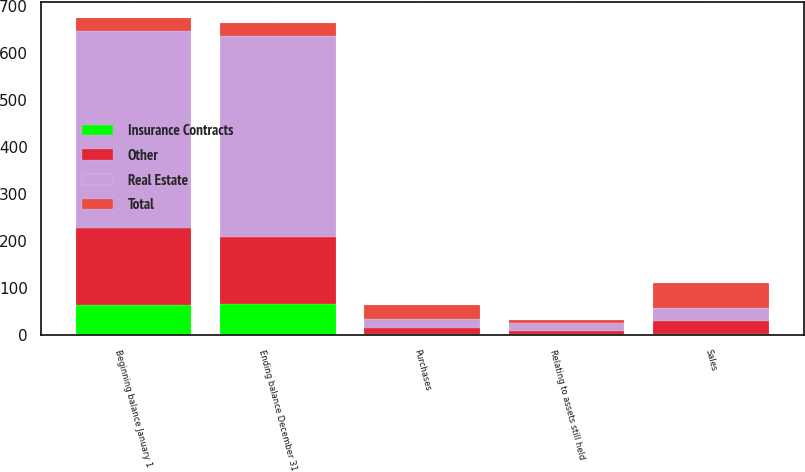Convert chart. <chart><loc_0><loc_0><loc_500><loc_500><stacked_bar_chart><ecel><fcel>Beginning balance January 1<fcel>Relating to assets still held<fcel>Purchases<fcel>Sales<fcel>Ending balance December 31<nl><fcel>Real Estate<fcel>420<fcel>16<fcel>19<fcel>28<fcel>428<nl><fcel>Other<fcel>165<fcel>7<fcel>13<fcel>27<fcel>144<nl><fcel>Insurance Contracts<fcel>63<fcel>2<fcel>3<fcel>3<fcel>65<nl><fcel>Total<fcel>27.5<fcel>7<fcel>29<fcel>52<fcel>27.5<nl></chart> 